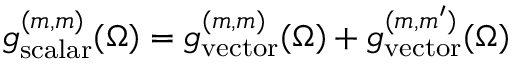<formula> <loc_0><loc_0><loc_500><loc_500>g _ { s c a l a r } ^ { ( m , m ) } ( \Omega ) = g _ { v e c t o r } ^ { ( m , m ) } ( \Omega ) + g _ { v e c t o r } ^ { ( m , m ^ { \prime } ) } ( \Omega )</formula> 